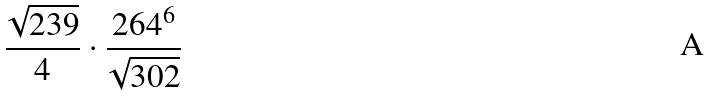<formula> <loc_0><loc_0><loc_500><loc_500>\frac { \sqrt { 2 3 9 } } { 4 } \cdot \frac { 2 6 4 ^ { 6 } } { \sqrt { 3 0 2 } }</formula> 